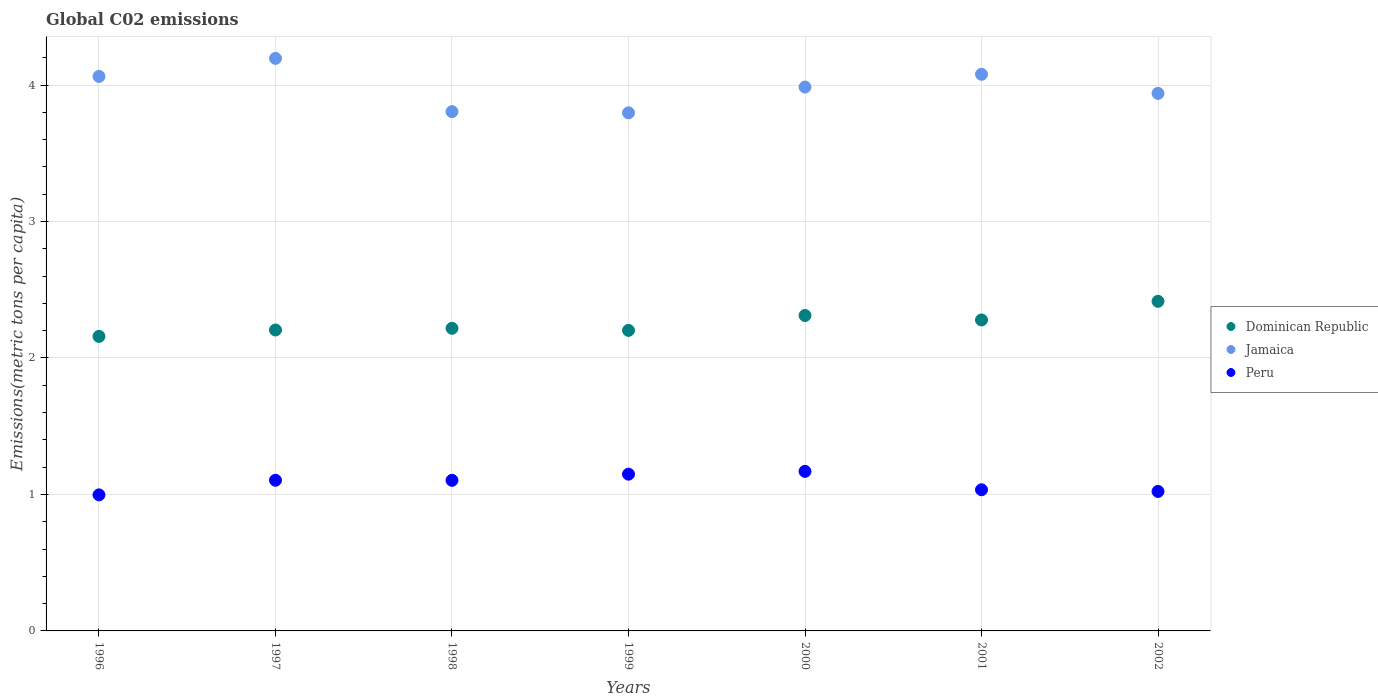Is the number of dotlines equal to the number of legend labels?
Provide a succinct answer. Yes. What is the amount of CO2 emitted in in Jamaica in 1999?
Provide a succinct answer. 3.8. Across all years, what is the maximum amount of CO2 emitted in in Dominican Republic?
Provide a short and direct response. 2.42. Across all years, what is the minimum amount of CO2 emitted in in Dominican Republic?
Your response must be concise. 2.16. In which year was the amount of CO2 emitted in in Peru maximum?
Give a very brief answer. 2000. What is the total amount of CO2 emitted in in Jamaica in the graph?
Give a very brief answer. 27.86. What is the difference between the amount of CO2 emitted in in Dominican Republic in 1999 and that in 2001?
Ensure brevity in your answer.  -0.08. What is the difference between the amount of CO2 emitted in in Jamaica in 1999 and the amount of CO2 emitted in in Peru in 1996?
Your answer should be compact. 2.8. What is the average amount of CO2 emitted in in Dominican Republic per year?
Your response must be concise. 2.26. In the year 2000, what is the difference between the amount of CO2 emitted in in Jamaica and amount of CO2 emitted in in Dominican Republic?
Your answer should be compact. 1.67. In how many years, is the amount of CO2 emitted in in Peru greater than 3.4 metric tons per capita?
Your answer should be compact. 0. What is the ratio of the amount of CO2 emitted in in Dominican Republic in 1999 to that in 2001?
Your response must be concise. 0.97. Is the difference between the amount of CO2 emitted in in Jamaica in 1998 and 2000 greater than the difference between the amount of CO2 emitted in in Dominican Republic in 1998 and 2000?
Make the answer very short. No. What is the difference between the highest and the second highest amount of CO2 emitted in in Jamaica?
Keep it short and to the point. 0.12. What is the difference between the highest and the lowest amount of CO2 emitted in in Peru?
Your answer should be very brief. 0.17. How many years are there in the graph?
Ensure brevity in your answer.  7. What is the difference between two consecutive major ticks on the Y-axis?
Offer a very short reply. 1. Are the values on the major ticks of Y-axis written in scientific E-notation?
Your response must be concise. No. Does the graph contain grids?
Your answer should be very brief. Yes. How many legend labels are there?
Keep it short and to the point. 3. What is the title of the graph?
Give a very brief answer. Global C02 emissions. What is the label or title of the X-axis?
Provide a short and direct response. Years. What is the label or title of the Y-axis?
Keep it short and to the point. Emissions(metric tons per capita). What is the Emissions(metric tons per capita) in Dominican Republic in 1996?
Provide a short and direct response. 2.16. What is the Emissions(metric tons per capita) of Jamaica in 1996?
Provide a short and direct response. 4.06. What is the Emissions(metric tons per capita) of Peru in 1996?
Your response must be concise. 1. What is the Emissions(metric tons per capita) in Dominican Republic in 1997?
Offer a very short reply. 2.21. What is the Emissions(metric tons per capita) of Jamaica in 1997?
Ensure brevity in your answer.  4.2. What is the Emissions(metric tons per capita) in Peru in 1997?
Your answer should be compact. 1.1. What is the Emissions(metric tons per capita) of Dominican Republic in 1998?
Ensure brevity in your answer.  2.22. What is the Emissions(metric tons per capita) in Jamaica in 1998?
Give a very brief answer. 3.81. What is the Emissions(metric tons per capita) in Peru in 1998?
Offer a terse response. 1.1. What is the Emissions(metric tons per capita) of Dominican Republic in 1999?
Keep it short and to the point. 2.2. What is the Emissions(metric tons per capita) in Jamaica in 1999?
Offer a very short reply. 3.8. What is the Emissions(metric tons per capita) in Peru in 1999?
Offer a very short reply. 1.15. What is the Emissions(metric tons per capita) of Dominican Republic in 2000?
Your answer should be very brief. 2.31. What is the Emissions(metric tons per capita) of Jamaica in 2000?
Give a very brief answer. 3.99. What is the Emissions(metric tons per capita) of Peru in 2000?
Offer a very short reply. 1.17. What is the Emissions(metric tons per capita) in Dominican Republic in 2001?
Your answer should be very brief. 2.28. What is the Emissions(metric tons per capita) of Jamaica in 2001?
Give a very brief answer. 4.08. What is the Emissions(metric tons per capita) in Peru in 2001?
Give a very brief answer. 1.03. What is the Emissions(metric tons per capita) in Dominican Republic in 2002?
Ensure brevity in your answer.  2.42. What is the Emissions(metric tons per capita) of Jamaica in 2002?
Ensure brevity in your answer.  3.94. What is the Emissions(metric tons per capita) in Peru in 2002?
Provide a short and direct response. 1.02. Across all years, what is the maximum Emissions(metric tons per capita) of Dominican Republic?
Keep it short and to the point. 2.42. Across all years, what is the maximum Emissions(metric tons per capita) of Jamaica?
Give a very brief answer. 4.2. Across all years, what is the maximum Emissions(metric tons per capita) of Peru?
Offer a very short reply. 1.17. Across all years, what is the minimum Emissions(metric tons per capita) of Dominican Republic?
Offer a terse response. 2.16. Across all years, what is the minimum Emissions(metric tons per capita) in Jamaica?
Keep it short and to the point. 3.8. Across all years, what is the minimum Emissions(metric tons per capita) in Peru?
Your answer should be very brief. 1. What is the total Emissions(metric tons per capita) of Dominican Republic in the graph?
Make the answer very short. 15.79. What is the total Emissions(metric tons per capita) of Jamaica in the graph?
Make the answer very short. 27.86. What is the total Emissions(metric tons per capita) in Peru in the graph?
Your answer should be compact. 7.58. What is the difference between the Emissions(metric tons per capita) of Dominican Republic in 1996 and that in 1997?
Provide a succinct answer. -0.05. What is the difference between the Emissions(metric tons per capita) in Jamaica in 1996 and that in 1997?
Keep it short and to the point. -0.13. What is the difference between the Emissions(metric tons per capita) of Peru in 1996 and that in 1997?
Make the answer very short. -0.11. What is the difference between the Emissions(metric tons per capita) of Dominican Republic in 1996 and that in 1998?
Make the answer very short. -0.06. What is the difference between the Emissions(metric tons per capita) of Jamaica in 1996 and that in 1998?
Your answer should be very brief. 0.26. What is the difference between the Emissions(metric tons per capita) of Peru in 1996 and that in 1998?
Keep it short and to the point. -0.11. What is the difference between the Emissions(metric tons per capita) of Dominican Republic in 1996 and that in 1999?
Give a very brief answer. -0.04. What is the difference between the Emissions(metric tons per capita) in Jamaica in 1996 and that in 1999?
Provide a short and direct response. 0.27. What is the difference between the Emissions(metric tons per capita) in Peru in 1996 and that in 1999?
Ensure brevity in your answer.  -0.15. What is the difference between the Emissions(metric tons per capita) of Dominican Republic in 1996 and that in 2000?
Give a very brief answer. -0.15. What is the difference between the Emissions(metric tons per capita) of Jamaica in 1996 and that in 2000?
Your answer should be compact. 0.08. What is the difference between the Emissions(metric tons per capita) of Peru in 1996 and that in 2000?
Make the answer very short. -0.17. What is the difference between the Emissions(metric tons per capita) of Dominican Republic in 1996 and that in 2001?
Offer a very short reply. -0.12. What is the difference between the Emissions(metric tons per capita) in Jamaica in 1996 and that in 2001?
Ensure brevity in your answer.  -0.02. What is the difference between the Emissions(metric tons per capita) of Peru in 1996 and that in 2001?
Offer a terse response. -0.04. What is the difference between the Emissions(metric tons per capita) in Dominican Republic in 1996 and that in 2002?
Your answer should be compact. -0.26. What is the difference between the Emissions(metric tons per capita) of Jamaica in 1996 and that in 2002?
Offer a terse response. 0.12. What is the difference between the Emissions(metric tons per capita) of Peru in 1996 and that in 2002?
Your answer should be very brief. -0.03. What is the difference between the Emissions(metric tons per capita) of Dominican Republic in 1997 and that in 1998?
Your response must be concise. -0.01. What is the difference between the Emissions(metric tons per capita) in Jamaica in 1997 and that in 1998?
Make the answer very short. 0.39. What is the difference between the Emissions(metric tons per capita) of Dominican Republic in 1997 and that in 1999?
Your response must be concise. 0. What is the difference between the Emissions(metric tons per capita) in Jamaica in 1997 and that in 1999?
Provide a short and direct response. 0.4. What is the difference between the Emissions(metric tons per capita) of Peru in 1997 and that in 1999?
Your response must be concise. -0.04. What is the difference between the Emissions(metric tons per capita) in Dominican Republic in 1997 and that in 2000?
Keep it short and to the point. -0.11. What is the difference between the Emissions(metric tons per capita) in Jamaica in 1997 and that in 2000?
Offer a terse response. 0.21. What is the difference between the Emissions(metric tons per capita) of Peru in 1997 and that in 2000?
Your answer should be very brief. -0.07. What is the difference between the Emissions(metric tons per capita) of Dominican Republic in 1997 and that in 2001?
Make the answer very short. -0.07. What is the difference between the Emissions(metric tons per capita) in Jamaica in 1997 and that in 2001?
Your response must be concise. 0.12. What is the difference between the Emissions(metric tons per capita) in Peru in 1997 and that in 2001?
Provide a succinct answer. 0.07. What is the difference between the Emissions(metric tons per capita) of Dominican Republic in 1997 and that in 2002?
Provide a short and direct response. -0.21. What is the difference between the Emissions(metric tons per capita) in Jamaica in 1997 and that in 2002?
Provide a succinct answer. 0.26. What is the difference between the Emissions(metric tons per capita) of Peru in 1997 and that in 2002?
Make the answer very short. 0.08. What is the difference between the Emissions(metric tons per capita) in Dominican Republic in 1998 and that in 1999?
Your answer should be compact. 0.02. What is the difference between the Emissions(metric tons per capita) in Jamaica in 1998 and that in 1999?
Make the answer very short. 0.01. What is the difference between the Emissions(metric tons per capita) in Peru in 1998 and that in 1999?
Your answer should be very brief. -0.05. What is the difference between the Emissions(metric tons per capita) in Dominican Republic in 1998 and that in 2000?
Your response must be concise. -0.09. What is the difference between the Emissions(metric tons per capita) in Jamaica in 1998 and that in 2000?
Your answer should be very brief. -0.18. What is the difference between the Emissions(metric tons per capita) of Peru in 1998 and that in 2000?
Ensure brevity in your answer.  -0.07. What is the difference between the Emissions(metric tons per capita) in Dominican Republic in 1998 and that in 2001?
Your response must be concise. -0.06. What is the difference between the Emissions(metric tons per capita) in Jamaica in 1998 and that in 2001?
Provide a succinct answer. -0.27. What is the difference between the Emissions(metric tons per capita) in Peru in 1998 and that in 2001?
Ensure brevity in your answer.  0.07. What is the difference between the Emissions(metric tons per capita) of Dominican Republic in 1998 and that in 2002?
Your answer should be compact. -0.2. What is the difference between the Emissions(metric tons per capita) in Jamaica in 1998 and that in 2002?
Keep it short and to the point. -0.13. What is the difference between the Emissions(metric tons per capita) in Peru in 1998 and that in 2002?
Give a very brief answer. 0.08. What is the difference between the Emissions(metric tons per capita) of Dominican Republic in 1999 and that in 2000?
Keep it short and to the point. -0.11. What is the difference between the Emissions(metric tons per capita) of Jamaica in 1999 and that in 2000?
Give a very brief answer. -0.19. What is the difference between the Emissions(metric tons per capita) of Peru in 1999 and that in 2000?
Make the answer very short. -0.02. What is the difference between the Emissions(metric tons per capita) of Dominican Republic in 1999 and that in 2001?
Provide a succinct answer. -0.08. What is the difference between the Emissions(metric tons per capita) in Jamaica in 1999 and that in 2001?
Your answer should be compact. -0.28. What is the difference between the Emissions(metric tons per capita) of Peru in 1999 and that in 2001?
Provide a short and direct response. 0.11. What is the difference between the Emissions(metric tons per capita) of Dominican Republic in 1999 and that in 2002?
Give a very brief answer. -0.21. What is the difference between the Emissions(metric tons per capita) in Jamaica in 1999 and that in 2002?
Ensure brevity in your answer.  -0.14. What is the difference between the Emissions(metric tons per capita) of Peru in 1999 and that in 2002?
Your answer should be compact. 0.13. What is the difference between the Emissions(metric tons per capita) of Dominican Republic in 2000 and that in 2001?
Make the answer very short. 0.03. What is the difference between the Emissions(metric tons per capita) in Jamaica in 2000 and that in 2001?
Your answer should be very brief. -0.09. What is the difference between the Emissions(metric tons per capita) in Peru in 2000 and that in 2001?
Offer a terse response. 0.13. What is the difference between the Emissions(metric tons per capita) of Dominican Republic in 2000 and that in 2002?
Keep it short and to the point. -0.1. What is the difference between the Emissions(metric tons per capita) of Jamaica in 2000 and that in 2002?
Your answer should be compact. 0.05. What is the difference between the Emissions(metric tons per capita) of Peru in 2000 and that in 2002?
Offer a terse response. 0.15. What is the difference between the Emissions(metric tons per capita) of Dominican Republic in 2001 and that in 2002?
Offer a very short reply. -0.14. What is the difference between the Emissions(metric tons per capita) of Jamaica in 2001 and that in 2002?
Keep it short and to the point. 0.14. What is the difference between the Emissions(metric tons per capita) of Peru in 2001 and that in 2002?
Provide a succinct answer. 0.01. What is the difference between the Emissions(metric tons per capita) of Dominican Republic in 1996 and the Emissions(metric tons per capita) of Jamaica in 1997?
Your response must be concise. -2.04. What is the difference between the Emissions(metric tons per capita) in Dominican Republic in 1996 and the Emissions(metric tons per capita) in Peru in 1997?
Keep it short and to the point. 1.05. What is the difference between the Emissions(metric tons per capita) in Jamaica in 1996 and the Emissions(metric tons per capita) in Peru in 1997?
Make the answer very short. 2.96. What is the difference between the Emissions(metric tons per capita) in Dominican Republic in 1996 and the Emissions(metric tons per capita) in Jamaica in 1998?
Your answer should be very brief. -1.65. What is the difference between the Emissions(metric tons per capita) of Dominican Republic in 1996 and the Emissions(metric tons per capita) of Peru in 1998?
Your answer should be compact. 1.05. What is the difference between the Emissions(metric tons per capita) in Jamaica in 1996 and the Emissions(metric tons per capita) in Peru in 1998?
Your answer should be very brief. 2.96. What is the difference between the Emissions(metric tons per capita) of Dominican Republic in 1996 and the Emissions(metric tons per capita) of Jamaica in 1999?
Offer a very short reply. -1.64. What is the difference between the Emissions(metric tons per capita) in Dominican Republic in 1996 and the Emissions(metric tons per capita) in Peru in 1999?
Your answer should be compact. 1.01. What is the difference between the Emissions(metric tons per capita) in Jamaica in 1996 and the Emissions(metric tons per capita) in Peru in 1999?
Keep it short and to the point. 2.91. What is the difference between the Emissions(metric tons per capita) of Dominican Republic in 1996 and the Emissions(metric tons per capita) of Jamaica in 2000?
Offer a very short reply. -1.83. What is the difference between the Emissions(metric tons per capita) in Dominican Republic in 1996 and the Emissions(metric tons per capita) in Peru in 2000?
Give a very brief answer. 0.99. What is the difference between the Emissions(metric tons per capita) of Jamaica in 1996 and the Emissions(metric tons per capita) of Peru in 2000?
Ensure brevity in your answer.  2.89. What is the difference between the Emissions(metric tons per capita) of Dominican Republic in 1996 and the Emissions(metric tons per capita) of Jamaica in 2001?
Offer a terse response. -1.92. What is the difference between the Emissions(metric tons per capita) in Dominican Republic in 1996 and the Emissions(metric tons per capita) in Peru in 2001?
Your answer should be compact. 1.12. What is the difference between the Emissions(metric tons per capita) of Jamaica in 1996 and the Emissions(metric tons per capita) of Peru in 2001?
Ensure brevity in your answer.  3.03. What is the difference between the Emissions(metric tons per capita) in Dominican Republic in 1996 and the Emissions(metric tons per capita) in Jamaica in 2002?
Offer a terse response. -1.78. What is the difference between the Emissions(metric tons per capita) in Dominican Republic in 1996 and the Emissions(metric tons per capita) in Peru in 2002?
Your response must be concise. 1.14. What is the difference between the Emissions(metric tons per capita) in Jamaica in 1996 and the Emissions(metric tons per capita) in Peru in 2002?
Your answer should be very brief. 3.04. What is the difference between the Emissions(metric tons per capita) of Dominican Republic in 1997 and the Emissions(metric tons per capita) of Jamaica in 1998?
Provide a short and direct response. -1.6. What is the difference between the Emissions(metric tons per capita) of Dominican Republic in 1997 and the Emissions(metric tons per capita) of Peru in 1998?
Your response must be concise. 1.1. What is the difference between the Emissions(metric tons per capita) of Jamaica in 1997 and the Emissions(metric tons per capita) of Peru in 1998?
Give a very brief answer. 3.09. What is the difference between the Emissions(metric tons per capita) of Dominican Republic in 1997 and the Emissions(metric tons per capita) of Jamaica in 1999?
Give a very brief answer. -1.59. What is the difference between the Emissions(metric tons per capita) in Dominican Republic in 1997 and the Emissions(metric tons per capita) in Peru in 1999?
Make the answer very short. 1.06. What is the difference between the Emissions(metric tons per capita) of Jamaica in 1997 and the Emissions(metric tons per capita) of Peru in 1999?
Your answer should be compact. 3.05. What is the difference between the Emissions(metric tons per capita) in Dominican Republic in 1997 and the Emissions(metric tons per capita) in Jamaica in 2000?
Provide a short and direct response. -1.78. What is the difference between the Emissions(metric tons per capita) in Dominican Republic in 1997 and the Emissions(metric tons per capita) in Peru in 2000?
Your answer should be compact. 1.04. What is the difference between the Emissions(metric tons per capita) of Jamaica in 1997 and the Emissions(metric tons per capita) of Peru in 2000?
Offer a terse response. 3.03. What is the difference between the Emissions(metric tons per capita) in Dominican Republic in 1997 and the Emissions(metric tons per capita) in Jamaica in 2001?
Give a very brief answer. -1.87. What is the difference between the Emissions(metric tons per capita) in Dominican Republic in 1997 and the Emissions(metric tons per capita) in Peru in 2001?
Provide a succinct answer. 1.17. What is the difference between the Emissions(metric tons per capita) in Jamaica in 1997 and the Emissions(metric tons per capita) in Peru in 2001?
Provide a succinct answer. 3.16. What is the difference between the Emissions(metric tons per capita) in Dominican Republic in 1997 and the Emissions(metric tons per capita) in Jamaica in 2002?
Ensure brevity in your answer.  -1.73. What is the difference between the Emissions(metric tons per capita) in Dominican Republic in 1997 and the Emissions(metric tons per capita) in Peru in 2002?
Offer a terse response. 1.18. What is the difference between the Emissions(metric tons per capita) of Jamaica in 1997 and the Emissions(metric tons per capita) of Peru in 2002?
Offer a very short reply. 3.17. What is the difference between the Emissions(metric tons per capita) in Dominican Republic in 1998 and the Emissions(metric tons per capita) in Jamaica in 1999?
Make the answer very short. -1.58. What is the difference between the Emissions(metric tons per capita) in Dominican Republic in 1998 and the Emissions(metric tons per capita) in Peru in 1999?
Provide a short and direct response. 1.07. What is the difference between the Emissions(metric tons per capita) in Jamaica in 1998 and the Emissions(metric tons per capita) in Peru in 1999?
Provide a succinct answer. 2.66. What is the difference between the Emissions(metric tons per capita) in Dominican Republic in 1998 and the Emissions(metric tons per capita) in Jamaica in 2000?
Your response must be concise. -1.77. What is the difference between the Emissions(metric tons per capita) of Dominican Republic in 1998 and the Emissions(metric tons per capita) of Peru in 2000?
Provide a succinct answer. 1.05. What is the difference between the Emissions(metric tons per capita) of Jamaica in 1998 and the Emissions(metric tons per capita) of Peru in 2000?
Make the answer very short. 2.64. What is the difference between the Emissions(metric tons per capita) in Dominican Republic in 1998 and the Emissions(metric tons per capita) in Jamaica in 2001?
Give a very brief answer. -1.86. What is the difference between the Emissions(metric tons per capita) in Dominican Republic in 1998 and the Emissions(metric tons per capita) in Peru in 2001?
Your answer should be compact. 1.18. What is the difference between the Emissions(metric tons per capita) of Jamaica in 1998 and the Emissions(metric tons per capita) of Peru in 2001?
Make the answer very short. 2.77. What is the difference between the Emissions(metric tons per capita) in Dominican Republic in 1998 and the Emissions(metric tons per capita) in Jamaica in 2002?
Make the answer very short. -1.72. What is the difference between the Emissions(metric tons per capita) of Dominican Republic in 1998 and the Emissions(metric tons per capita) of Peru in 2002?
Ensure brevity in your answer.  1.2. What is the difference between the Emissions(metric tons per capita) of Jamaica in 1998 and the Emissions(metric tons per capita) of Peru in 2002?
Provide a short and direct response. 2.78. What is the difference between the Emissions(metric tons per capita) in Dominican Republic in 1999 and the Emissions(metric tons per capita) in Jamaica in 2000?
Offer a very short reply. -1.78. What is the difference between the Emissions(metric tons per capita) of Dominican Republic in 1999 and the Emissions(metric tons per capita) of Peru in 2000?
Keep it short and to the point. 1.03. What is the difference between the Emissions(metric tons per capita) of Jamaica in 1999 and the Emissions(metric tons per capita) of Peru in 2000?
Give a very brief answer. 2.63. What is the difference between the Emissions(metric tons per capita) of Dominican Republic in 1999 and the Emissions(metric tons per capita) of Jamaica in 2001?
Offer a very short reply. -1.88. What is the difference between the Emissions(metric tons per capita) of Dominican Republic in 1999 and the Emissions(metric tons per capita) of Peru in 2001?
Ensure brevity in your answer.  1.17. What is the difference between the Emissions(metric tons per capita) of Jamaica in 1999 and the Emissions(metric tons per capita) of Peru in 2001?
Make the answer very short. 2.76. What is the difference between the Emissions(metric tons per capita) in Dominican Republic in 1999 and the Emissions(metric tons per capita) in Jamaica in 2002?
Offer a very short reply. -1.74. What is the difference between the Emissions(metric tons per capita) in Dominican Republic in 1999 and the Emissions(metric tons per capita) in Peru in 2002?
Make the answer very short. 1.18. What is the difference between the Emissions(metric tons per capita) of Jamaica in 1999 and the Emissions(metric tons per capita) of Peru in 2002?
Keep it short and to the point. 2.77. What is the difference between the Emissions(metric tons per capita) of Dominican Republic in 2000 and the Emissions(metric tons per capita) of Jamaica in 2001?
Make the answer very short. -1.77. What is the difference between the Emissions(metric tons per capita) in Dominican Republic in 2000 and the Emissions(metric tons per capita) in Peru in 2001?
Your answer should be compact. 1.28. What is the difference between the Emissions(metric tons per capita) of Jamaica in 2000 and the Emissions(metric tons per capita) of Peru in 2001?
Your answer should be compact. 2.95. What is the difference between the Emissions(metric tons per capita) of Dominican Republic in 2000 and the Emissions(metric tons per capita) of Jamaica in 2002?
Your answer should be very brief. -1.63. What is the difference between the Emissions(metric tons per capita) of Dominican Republic in 2000 and the Emissions(metric tons per capita) of Peru in 2002?
Offer a terse response. 1.29. What is the difference between the Emissions(metric tons per capita) in Jamaica in 2000 and the Emissions(metric tons per capita) in Peru in 2002?
Make the answer very short. 2.96. What is the difference between the Emissions(metric tons per capita) in Dominican Republic in 2001 and the Emissions(metric tons per capita) in Jamaica in 2002?
Ensure brevity in your answer.  -1.66. What is the difference between the Emissions(metric tons per capita) in Dominican Republic in 2001 and the Emissions(metric tons per capita) in Peru in 2002?
Your response must be concise. 1.26. What is the difference between the Emissions(metric tons per capita) in Jamaica in 2001 and the Emissions(metric tons per capita) in Peru in 2002?
Give a very brief answer. 3.06. What is the average Emissions(metric tons per capita) of Dominican Republic per year?
Ensure brevity in your answer.  2.26. What is the average Emissions(metric tons per capita) of Jamaica per year?
Ensure brevity in your answer.  3.98. What is the average Emissions(metric tons per capita) of Peru per year?
Your answer should be very brief. 1.08. In the year 1996, what is the difference between the Emissions(metric tons per capita) of Dominican Republic and Emissions(metric tons per capita) of Jamaica?
Provide a succinct answer. -1.91. In the year 1996, what is the difference between the Emissions(metric tons per capita) in Dominican Republic and Emissions(metric tons per capita) in Peru?
Provide a succinct answer. 1.16. In the year 1996, what is the difference between the Emissions(metric tons per capita) in Jamaica and Emissions(metric tons per capita) in Peru?
Offer a terse response. 3.07. In the year 1997, what is the difference between the Emissions(metric tons per capita) of Dominican Republic and Emissions(metric tons per capita) of Jamaica?
Provide a short and direct response. -1.99. In the year 1997, what is the difference between the Emissions(metric tons per capita) of Dominican Republic and Emissions(metric tons per capita) of Peru?
Ensure brevity in your answer.  1.1. In the year 1997, what is the difference between the Emissions(metric tons per capita) of Jamaica and Emissions(metric tons per capita) of Peru?
Offer a terse response. 3.09. In the year 1998, what is the difference between the Emissions(metric tons per capita) of Dominican Republic and Emissions(metric tons per capita) of Jamaica?
Offer a very short reply. -1.59. In the year 1998, what is the difference between the Emissions(metric tons per capita) in Dominican Republic and Emissions(metric tons per capita) in Peru?
Ensure brevity in your answer.  1.11. In the year 1998, what is the difference between the Emissions(metric tons per capita) of Jamaica and Emissions(metric tons per capita) of Peru?
Your response must be concise. 2.7. In the year 1999, what is the difference between the Emissions(metric tons per capita) of Dominican Republic and Emissions(metric tons per capita) of Jamaica?
Your answer should be compact. -1.59. In the year 1999, what is the difference between the Emissions(metric tons per capita) of Dominican Republic and Emissions(metric tons per capita) of Peru?
Keep it short and to the point. 1.05. In the year 1999, what is the difference between the Emissions(metric tons per capita) of Jamaica and Emissions(metric tons per capita) of Peru?
Provide a short and direct response. 2.65. In the year 2000, what is the difference between the Emissions(metric tons per capita) of Dominican Republic and Emissions(metric tons per capita) of Jamaica?
Ensure brevity in your answer.  -1.67. In the year 2000, what is the difference between the Emissions(metric tons per capita) in Dominican Republic and Emissions(metric tons per capita) in Peru?
Your answer should be compact. 1.14. In the year 2000, what is the difference between the Emissions(metric tons per capita) in Jamaica and Emissions(metric tons per capita) in Peru?
Provide a succinct answer. 2.82. In the year 2001, what is the difference between the Emissions(metric tons per capita) of Dominican Republic and Emissions(metric tons per capita) of Jamaica?
Your answer should be compact. -1.8. In the year 2001, what is the difference between the Emissions(metric tons per capita) in Dominican Republic and Emissions(metric tons per capita) in Peru?
Your response must be concise. 1.24. In the year 2001, what is the difference between the Emissions(metric tons per capita) in Jamaica and Emissions(metric tons per capita) in Peru?
Provide a short and direct response. 3.04. In the year 2002, what is the difference between the Emissions(metric tons per capita) of Dominican Republic and Emissions(metric tons per capita) of Jamaica?
Ensure brevity in your answer.  -1.52. In the year 2002, what is the difference between the Emissions(metric tons per capita) in Dominican Republic and Emissions(metric tons per capita) in Peru?
Offer a very short reply. 1.39. In the year 2002, what is the difference between the Emissions(metric tons per capita) in Jamaica and Emissions(metric tons per capita) in Peru?
Ensure brevity in your answer.  2.92. What is the ratio of the Emissions(metric tons per capita) of Dominican Republic in 1996 to that in 1997?
Your answer should be very brief. 0.98. What is the ratio of the Emissions(metric tons per capita) in Jamaica in 1996 to that in 1997?
Keep it short and to the point. 0.97. What is the ratio of the Emissions(metric tons per capita) of Peru in 1996 to that in 1997?
Your answer should be very brief. 0.9. What is the ratio of the Emissions(metric tons per capita) of Dominican Republic in 1996 to that in 1998?
Offer a terse response. 0.97. What is the ratio of the Emissions(metric tons per capita) of Jamaica in 1996 to that in 1998?
Make the answer very short. 1.07. What is the ratio of the Emissions(metric tons per capita) of Peru in 1996 to that in 1998?
Keep it short and to the point. 0.9. What is the ratio of the Emissions(metric tons per capita) in Dominican Republic in 1996 to that in 1999?
Your response must be concise. 0.98. What is the ratio of the Emissions(metric tons per capita) of Jamaica in 1996 to that in 1999?
Provide a succinct answer. 1.07. What is the ratio of the Emissions(metric tons per capita) of Peru in 1996 to that in 1999?
Provide a succinct answer. 0.87. What is the ratio of the Emissions(metric tons per capita) in Dominican Republic in 1996 to that in 2000?
Make the answer very short. 0.93. What is the ratio of the Emissions(metric tons per capita) in Jamaica in 1996 to that in 2000?
Provide a short and direct response. 1.02. What is the ratio of the Emissions(metric tons per capita) in Peru in 1996 to that in 2000?
Ensure brevity in your answer.  0.85. What is the ratio of the Emissions(metric tons per capita) of Dominican Republic in 1996 to that in 2001?
Keep it short and to the point. 0.95. What is the ratio of the Emissions(metric tons per capita) of Peru in 1996 to that in 2001?
Provide a short and direct response. 0.96. What is the ratio of the Emissions(metric tons per capita) in Dominican Republic in 1996 to that in 2002?
Make the answer very short. 0.89. What is the ratio of the Emissions(metric tons per capita) in Jamaica in 1996 to that in 2002?
Keep it short and to the point. 1.03. What is the ratio of the Emissions(metric tons per capita) of Peru in 1996 to that in 2002?
Ensure brevity in your answer.  0.98. What is the ratio of the Emissions(metric tons per capita) of Dominican Republic in 1997 to that in 1998?
Provide a short and direct response. 0.99. What is the ratio of the Emissions(metric tons per capita) of Jamaica in 1997 to that in 1998?
Make the answer very short. 1.1. What is the ratio of the Emissions(metric tons per capita) in Peru in 1997 to that in 1998?
Provide a succinct answer. 1. What is the ratio of the Emissions(metric tons per capita) in Dominican Republic in 1997 to that in 1999?
Offer a very short reply. 1. What is the ratio of the Emissions(metric tons per capita) in Jamaica in 1997 to that in 1999?
Provide a succinct answer. 1.11. What is the ratio of the Emissions(metric tons per capita) of Peru in 1997 to that in 1999?
Make the answer very short. 0.96. What is the ratio of the Emissions(metric tons per capita) of Dominican Republic in 1997 to that in 2000?
Offer a terse response. 0.95. What is the ratio of the Emissions(metric tons per capita) in Jamaica in 1997 to that in 2000?
Provide a short and direct response. 1.05. What is the ratio of the Emissions(metric tons per capita) in Peru in 1997 to that in 2000?
Your response must be concise. 0.94. What is the ratio of the Emissions(metric tons per capita) of Dominican Republic in 1997 to that in 2001?
Offer a terse response. 0.97. What is the ratio of the Emissions(metric tons per capita) in Jamaica in 1997 to that in 2001?
Give a very brief answer. 1.03. What is the ratio of the Emissions(metric tons per capita) in Peru in 1997 to that in 2001?
Give a very brief answer. 1.07. What is the ratio of the Emissions(metric tons per capita) in Jamaica in 1997 to that in 2002?
Your answer should be compact. 1.07. What is the ratio of the Emissions(metric tons per capita) in Peru in 1997 to that in 2002?
Make the answer very short. 1.08. What is the ratio of the Emissions(metric tons per capita) in Jamaica in 1998 to that in 1999?
Offer a very short reply. 1. What is the ratio of the Emissions(metric tons per capita) in Peru in 1998 to that in 1999?
Make the answer very short. 0.96. What is the ratio of the Emissions(metric tons per capita) of Dominican Republic in 1998 to that in 2000?
Offer a terse response. 0.96. What is the ratio of the Emissions(metric tons per capita) of Jamaica in 1998 to that in 2000?
Offer a very short reply. 0.95. What is the ratio of the Emissions(metric tons per capita) in Peru in 1998 to that in 2000?
Your response must be concise. 0.94. What is the ratio of the Emissions(metric tons per capita) in Dominican Republic in 1998 to that in 2001?
Your response must be concise. 0.97. What is the ratio of the Emissions(metric tons per capita) in Jamaica in 1998 to that in 2001?
Offer a terse response. 0.93. What is the ratio of the Emissions(metric tons per capita) of Peru in 1998 to that in 2001?
Ensure brevity in your answer.  1.07. What is the ratio of the Emissions(metric tons per capita) in Dominican Republic in 1998 to that in 2002?
Your response must be concise. 0.92. What is the ratio of the Emissions(metric tons per capita) in Jamaica in 1998 to that in 2002?
Offer a very short reply. 0.97. What is the ratio of the Emissions(metric tons per capita) in Peru in 1998 to that in 2002?
Offer a terse response. 1.08. What is the ratio of the Emissions(metric tons per capita) in Dominican Republic in 1999 to that in 2000?
Ensure brevity in your answer.  0.95. What is the ratio of the Emissions(metric tons per capita) of Jamaica in 1999 to that in 2000?
Offer a terse response. 0.95. What is the ratio of the Emissions(metric tons per capita) in Peru in 1999 to that in 2000?
Provide a short and direct response. 0.98. What is the ratio of the Emissions(metric tons per capita) of Dominican Republic in 1999 to that in 2001?
Your answer should be very brief. 0.97. What is the ratio of the Emissions(metric tons per capita) of Jamaica in 1999 to that in 2001?
Provide a short and direct response. 0.93. What is the ratio of the Emissions(metric tons per capita) of Peru in 1999 to that in 2001?
Make the answer very short. 1.11. What is the ratio of the Emissions(metric tons per capita) in Dominican Republic in 1999 to that in 2002?
Provide a short and direct response. 0.91. What is the ratio of the Emissions(metric tons per capita) of Jamaica in 1999 to that in 2002?
Give a very brief answer. 0.96. What is the ratio of the Emissions(metric tons per capita) of Peru in 1999 to that in 2002?
Give a very brief answer. 1.12. What is the ratio of the Emissions(metric tons per capita) in Dominican Republic in 2000 to that in 2001?
Your response must be concise. 1.01. What is the ratio of the Emissions(metric tons per capita) in Jamaica in 2000 to that in 2001?
Your answer should be very brief. 0.98. What is the ratio of the Emissions(metric tons per capita) in Peru in 2000 to that in 2001?
Your answer should be compact. 1.13. What is the ratio of the Emissions(metric tons per capita) in Jamaica in 2000 to that in 2002?
Provide a short and direct response. 1.01. What is the ratio of the Emissions(metric tons per capita) in Peru in 2000 to that in 2002?
Give a very brief answer. 1.14. What is the ratio of the Emissions(metric tons per capita) in Dominican Republic in 2001 to that in 2002?
Offer a very short reply. 0.94. What is the ratio of the Emissions(metric tons per capita) in Jamaica in 2001 to that in 2002?
Keep it short and to the point. 1.04. What is the ratio of the Emissions(metric tons per capita) in Peru in 2001 to that in 2002?
Offer a terse response. 1.01. What is the difference between the highest and the second highest Emissions(metric tons per capita) of Dominican Republic?
Provide a short and direct response. 0.1. What is the difference between the highest and the second highest Emissions(metric tons per capita) of Jamaica?
Your answer should be compact. 0.12. What is the difference between the highest and the second highest Emissions(metric tons per capita) in Peru?
Make the answer very short. 0.02. What is the difference between the highest and the lowest Emissions(metric tons per capita) in Dominican Republic?
Provide a succinct answer. 0.26. What is the difference between the highest and the lowest Emissions(metric tons per capita) of Jamaica?
Keep it short and to the point. 0.4. What is the difference between the highest and the lowest Emissions(metric tons per capita) of Peru?
Offer a very short reply. 0.17. 